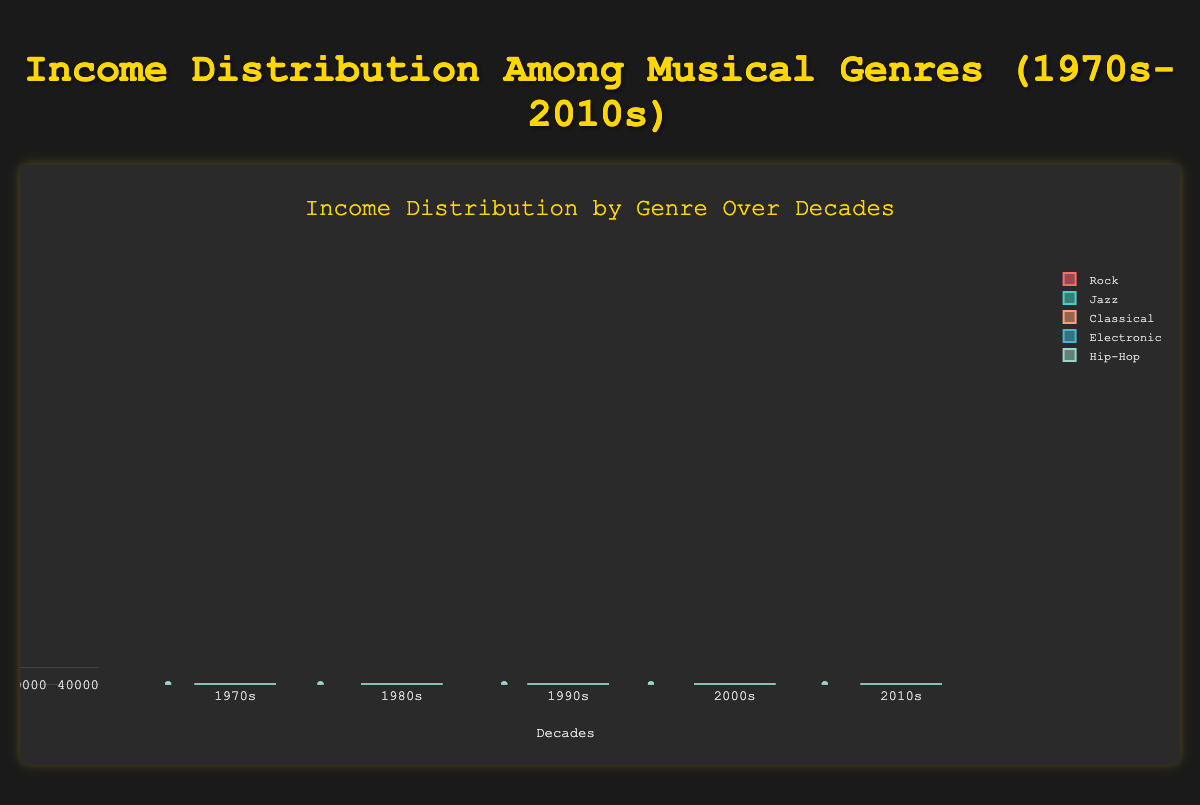What's the title of this box plot? The title of the box plot is displayed prominently at the top of the figure. It reads "Income Distribution Among Musical Genres (1970s-2010s)".
Answer: Income Distribution Among Musical Genres (1970s-2010s) Which genre had the highest median income in the 2010s? To find the highest median income, look at the central line in each box for the 2010s. The central line in the box plot for Hip-Hop is the highest among all genres.
Answer: Hip-Hop How does the income distribution of Rock compare between the 1970s and the 2010s? Compare the box plots for Rock in the 1970s and 2010s. The median, represented by the line inside the box, has increased, and the overall range (interquartile range and whiskers) has also shifted up, indicating higher incomes.
Answer: The income distribution shifted upwards What is the median income for Jazz musicians in the 1980s? Look at the box plot for Jazz in the 1980s and find the central line inside the box, which represents the median income.
Answer: $29000 Which genre shows the greatest increase in median income from the 1970s to the 2010s? Compare the median lines for each genre between the 1970s and 2010s. The genre with the largest difference in median income lines is Hip-Hop.
Answer: Hip-Hop How many genres saw a median income increase in every decade from the 1970s to the 2010s? Check the median line in each box for all decades. Genres Rock, Jazz, Classical, Electronic, and Hip-Hop all show an increasing trend in median income through each decade.
Answer: 5 Which decade had the lowest median income for Electronic music? Look at the central lines in the box plots for Electronic music across all decades. The lowest median income is in the 1970s.
Answer: 1970s What is the range of incomes for Jazz musicians in the 2000s? Identify the minimum and maximum whiskers (ends of the dash lines) for Jazz in the 2000s. The range is from approximately $30000 to $45000.
Answer: $30000 to $45000 Compare the interquartile range (IQR) of Classical and Hip-Hop in the 1990s. Which one is greater? The IQR is the width of the box itself. By comparing the boxes, it is clear that the IQR of Hip-Hop is wider than Classical in the 1990s.
Answer: Hip-Hop 